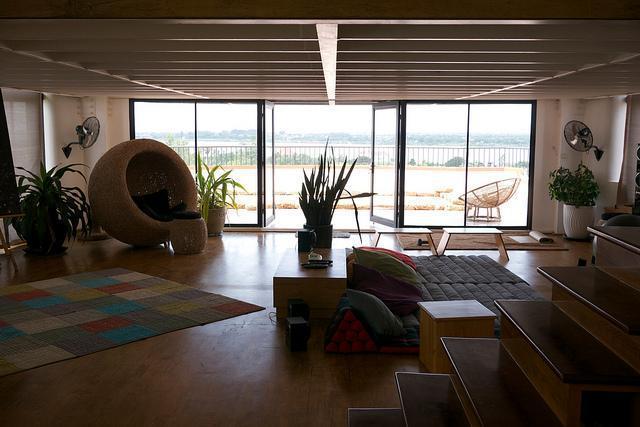How many red squares can you see on the rug?
Give a very brief answer. 4. How many potted plants are visible?
Give a very brief answer. 4. How many chairs don't have a dog on them?
Give a very brief answer. 0. 